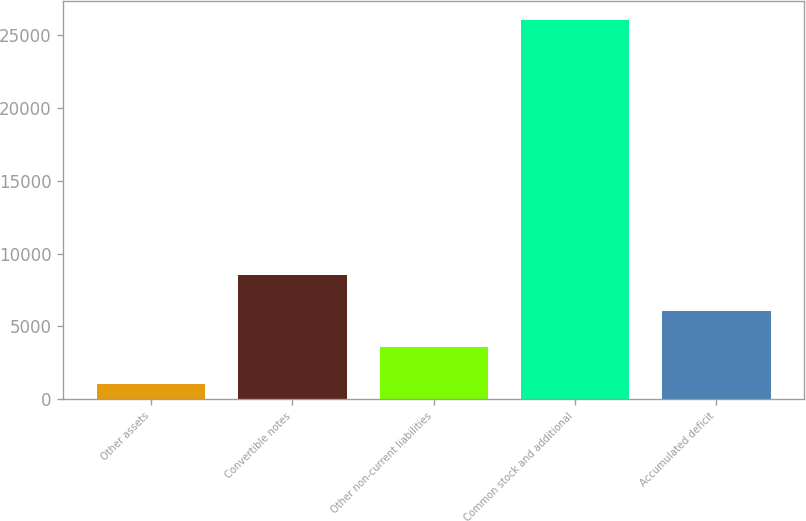Convert chart to OTSL. <chart><loc_0><loc_0><loc_500><loc_500><bar_chart><fcel>Other assets<fcel>Convertible notes<fcel>Other non-current liabilities<fcel>Common stock and additional<fcel>Accumulated deficit<nl><fcel>1069<fcel>8557.3<fcel>3565.1<fcel>26030<fcel>6061.2<nl></chart> 